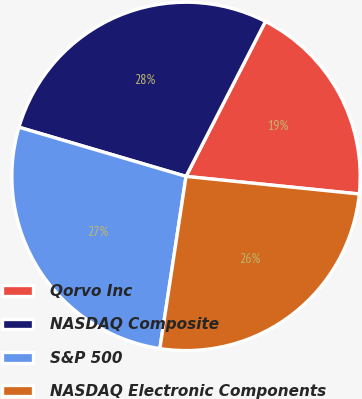<chart> <loc_0><loc_0><loc_500><loc_500><pie_chart><fcel>Qorvo Inc<fcel>NASDAQ Composite<fcel>S&P 500<fcel>NASDAQ Electronic Components<nl><fcel>19.08%<fcel>27.98%<fcel>27.16%<fcel>25.79%<nl></chart> 